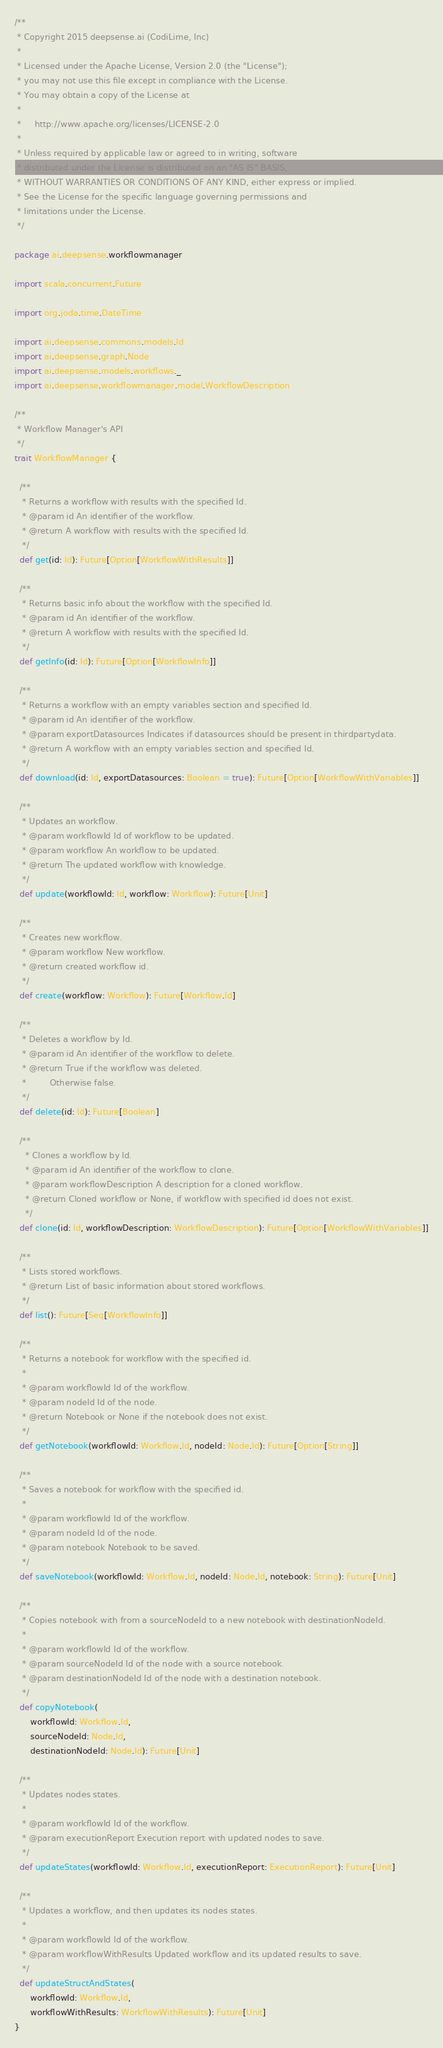Convert code to text. <code><loc_0><loc_0><loc_500><loc_500><_Scala_>/**
 * Copyright 2015 deepsense.ai (CodiLime, Inc)
 *
 * Licensed under the Apache License, Version 2.0 (the "License");
 * you may not use this file except in compliance with the License.
 * You may obtain a copy of the License at
 *
 *     http://www.apache.org/licenses/LICENSE-2.0
 *
 * Unless required by applicable law or agreed to in writing, software
 * distributed under the License is distributed on an "AS IS" BASIS,
 * WITHOUT WARRANTIES OR CONDITIONS OF ANY KIND, either express or implied.
 * See the License for the specific language governing permissions and
 * limitations under the License.
 */

package ai.deepsense.workflowmanager

import scala.concurrent.Future

import org.joda.time.DateTime

import ai.deepsense.commons.models.Id
import ai.deepsense.graph.Node
import ai.deepsense.models.workflows._
import ai.deepsense.workflowmanager.model.WorkflowDescription

/**
 * Workflow Manager's API
 */
trait WorkflowManager {

  /**
   * Returns a workflow with results with the specified Id.
   * @param id An identifier of the workflow.
   * @return A workflow with results with the specified Id.
   */
  def get(id: Id): Future[Option[WorkflowWithResults]]

  /**
   * Returns basic info about the workflow with the specified Id.
   * @param id An identifier of the workflow.
   * @return A workflow with results with the specified Id.
   */
  def getInfo(id: Id): Future[Option[WorkflowInfo]]

  /**
   * Returns a workflow with an empty variables section and specified Id.
   * @param id An identifier of the workflow.
   * @param exportDatasources Indicates if datasources should be present in thirdpartydata.
   * @return A workflow with an empty variables section and specified Id.
   */
  def download(id: Id, exportDatasources: Boolean = true): Future[Option[WorkflowWithVariables]]

  /**
   * Updates an workflow.
   * @param workflowId Id of workflow to be updated.
   * @param workflow An workflow to be updated.
   * @return The updated workflow with knowledge.
   */
  def update(workflowId: Id, workflow: Workflow): Future[Unit]

  /**
   * Creates new workflow.
   * @param workflow New workflow.
   * @return created workflow id.
   */
  def create(workflow: Workflow): Future[Workflow.Id]

  /**
   * Deletes a workflow by Id.
   * @param id An identifier of the workflow to delete.
   * @return True if the workflow was deleted.
   *         Otherwise false.
   */
  def delete(id: Id): Future[Boolean]

  /**
    * Clones a workflow by Id.
    * @param id An identifier of the workflow to clone.
    * @param workflowDescription A description for a cloned workflow.
    * @return Cloned workflow or None, if workflow with specified id does not exist.
    */
  def clone(id: Id, workflowDescription: WorkflowDescription): Future[Option[WorkflowWithVariables]]

  /**
   * Lists stored workflows.
   * @return List of basic information about stored workflows.
   */
  def list(): Future[Seq[WorkflowInfo]]

  /**
   * Returns a notebook for workflow with the specified id.
   *
   * @param workflowId Id of the workflow.
   * @param nodeId Id of the node.
   * @return Notebook or None if the notebook does not exist.
   */
  def getNotebook(workflowId: Workflow.Id, nodeId: Node.Id): Future[Option[String]]

  /**
   * Saves a notebook for workflow with the specified id.
   *
   * @param workflowId Id of the workflow.
   * @param nodeId Id of the node.
   * @param notebook Notebook to be saved.
   */
  def saveNotebook(workflowId: Workflow.Id, nodeId: Node.Id, notebook: String): Future[Unit]

  /**
   * Copies notebook with from a sourceNodeId to a new notebook with destinationNodeId.
   *
   * @param workflowId Id of the workflow.
   * @param sourceNodeId Id of the node with a source notebook.
   * @param destinationNodeId Id of the node with a destination notebook.
   */
  def copyNotebook(
      workflowId: Workflow.Id,
      sourceNodeId: Node.Id,
      destinationNodeId: Node.Id): Future[Unit]

  /**
   * Updates nodes states.
   *
   * @param workflowId Id of the workflow.
   * @param executionReport Execution report with updated nodes to save.
   */
  def updateStates(workflowId: Workflow.Id, executionReport: ExecutionReport): Future[Unit]

  /**
   * Updates a workflow, and then updates its nodes states.
   *
   * @param workflowId Id of the workflow.
   * @param workflowWithResults Updated workflow and its updated results to save.
   */
  def updateStructAndStates(
      workflowId: Workflow.Id,
      workflowWithResults: WorkflowWithResults): Future[Unit]
}
</code> 